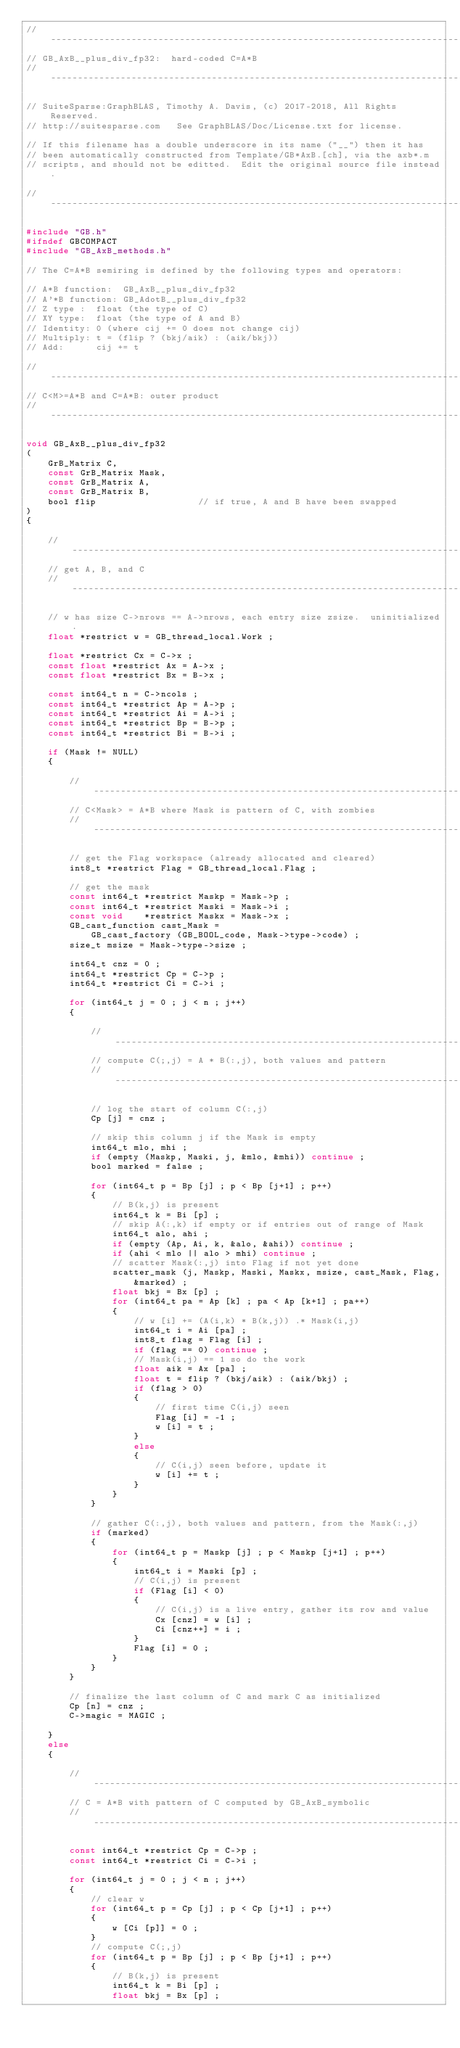Convert code to text. <code><loc_0><loc_0><loc_500><loc_500><_C_>//------------------------------------------------------------------------------
// GB_AxB__plus_div_fp32:  hard-coded C=A*B
//------------------------------------------------------------------------------

// SuiteSparse:GraphBLAS, Timothy A. Davis, (c) 2017-2018, All Rights Reserved.
// http://suitesparse.com   See GraphBLAS/Doc/License.txt for license.

// If this filename has a double underscore in its name ("__") then it has
// been automatically constructed from Template/GB*AxB.[ch], via the axb*.m
// scripts, and should not be editted.  Edit the original source file instead.

//------------------------------------------------------------------------------

#include "GB.h"
#ifndef GBCOMPACT
#include "GB_AxB_methods.h"

// The C=A*B semiring is defined by the following types and operators:

// A*B function:  GB_AxB__plus_div_fp32
// A'*B function: GB_AdotB__plus_div_fp32
// Z type :  float (the type of C)
// XY type:  float (the type of A and B)
// Identity: 0 (where cij += 0 does not change cij)
// Multiply: t = (flip ? (bkj/aik) : (aik/bkj))
// Add:      cij += t

//------------------------------------------------------------------------------
// C<M>=A*B and C=A*B: outer product
//------------------------------------------------------------------------------

void GB_AxB__plus_div_fp32
(
    GrB_Matrix C,
    const GrB_Matrix Mask,
    const GrB_Matrix A,
    const GrB_Matrix B,
    bool flip                   // if true, A and B have been swapped
)
{

    //--------------------------------------------------------------------------
    // get A, B, and C
    //--------------------------------------------------------------------------

    // w has size C->nrows == A->nrows, each entry size zsize.  uninitialized.
    float *restrict w = GB_thread_local.Work ;

    float *restrict Cx = C->x ;
    const float *restrict Ax = A->x ;
    const float *restrict Bx = B->x ;

    const int64_t n = C->ncols ;
    const int64_t *restrict Ap = A->p ;
    const int64_t *restrict Ai = A->i ;
    const int64_t *restrict Bp = B->p ;
    const int64_t *restrict Bi = B->i ;

    if (Mask != NULL)
    {

        //----------------------------------------------------------------------
        // C<Mask> = A*B where Mask is pattern of C, with zombies
        //----------------------------------------------------------------------

        // get the Flag workspace (already allocated and cleared)
        int8_t *restrict Flag = GB_thread_local.Flag ;

        // get the mask
        const int64_t *restrict Maskp = Mask->p ;
        const int64_t *restrict Maski = Mask->i ;
        const void    *restrict Maskx = Mask->x ;
        GB_cast_function cast_Mask =
            GB_cast_factory (GB_BOOL_code, Mask->type->code) ;
        size_t msize = Mask->type->size ;

        int64_t cnz = 0 ;
        int64_t *restrict Cp = C->p ;
        int64_t *restrict Ci = C->i ;

        for (int64_t j = 0 ; j < n ; j++)
        {

            //------------------------------------------------------------------
            // compute C(;,j) = A * B(:,j), both values and pattern
            //------------------------------------------------------------------

            // log the start of column C(:,j)
            Cp [j] = cnz ;

            // skip this column j if the Mask is empty
            int64_t mlo, mhi ;
            if (empty (Maskp, Maski, j, &mlo, &mhi)) continue ;
            bool marked = false ;

            for (int64_t p = Bp [j] ; p < Bp [j+1] ; p++)
            {
                // B(k,j) is present
                int64_t k = Bi [p] ;
                // skip A(:,k) if empty or if entries out of range of Mask
                int64_t alo, ahi ;
                if (empty (Ap, Ai, k, &alo, &ahi)) continue ;
                if (ahi < mlo || alo > mhi) continue ;
                // scatter Mask(:,j) into Flag if not yet done
                scatter_mask (j, Maskp, Maski, Maskx, msize, cast_Mask, Flag,
                    &marked) ;
                float bkj = Bx [p] ;
                for (int64_t pa = Ap [k] ; pa < Ap [k+1] ; pa++)
                {
                    // w [i] += (A(i,k) * B(k,j)) .* Mask(i,j)
                    int64_t i = Ai [pa] ;
                    int8_t flag = Flag [i] ;
                    if (flag == 0) continue ;
                    // Mask(i,j) == 1 so do the work
                    float aik = Ax [pa] ;
                    float t = flip ? (bkj/aik) : (aik/bkj) ;
                    if (flag > 0)
                    {
                        // first time C(i,j) seen
                        Flag [i] = -1 ;
                        w [i] = t ;
                    }
                    else
                    {
                        // C(i,j) seen before, update it
                        w [i] += t ;
                    }
                }
            }

            // gather C(:,j), both values and pattern, from the Mask(:,j)
            if (marked)
            {
                for (int64_t p = Maskp [j] ; p < Maskp [j+1] ; p++)
                {
                    int64_t i = Maski [p] ;
                    // C(i,j) is present
                    if (Flag [i] < 0)
                    {
                        // C(i,j) is a live entry, gather its row and value
                        Cx [cnz] = w [i] ;
                        Ci [cnz++] = i ;
                    }
                    Flag [i] = 0 ;
                }
            }
        }

        // finalize the last column of C and mark C as initialized
        Cp [n] = cnz ;
        C->magic = MAGIC ;

    }
    else
    {

        //----------------------------------------------------------------------
        // C = A*B with pattern of C computed by GB_AxB_symbolic
        //----------------------------------------------------------------------

        const int64_t *restrict Cp = C->p ;
        const int64_t *restrict Ci = C->i ;

        for (int64_t j = 0 ; j < n ; j++)
        {
            // clear w
            for (int64_t p = Cp [j] ; p < Cp [j+1] ; p++)
            {
                w [Ci [p]] = 0 ;
            }
            // compute C(;,j)
            for (int64_t p = Bp [j] ; p < Bp [j+1] ; p++)
            {
                // B(k,j) is present
                int64_t k = Bi [p] ;
                float bkj = Bx [p] ;</code> 